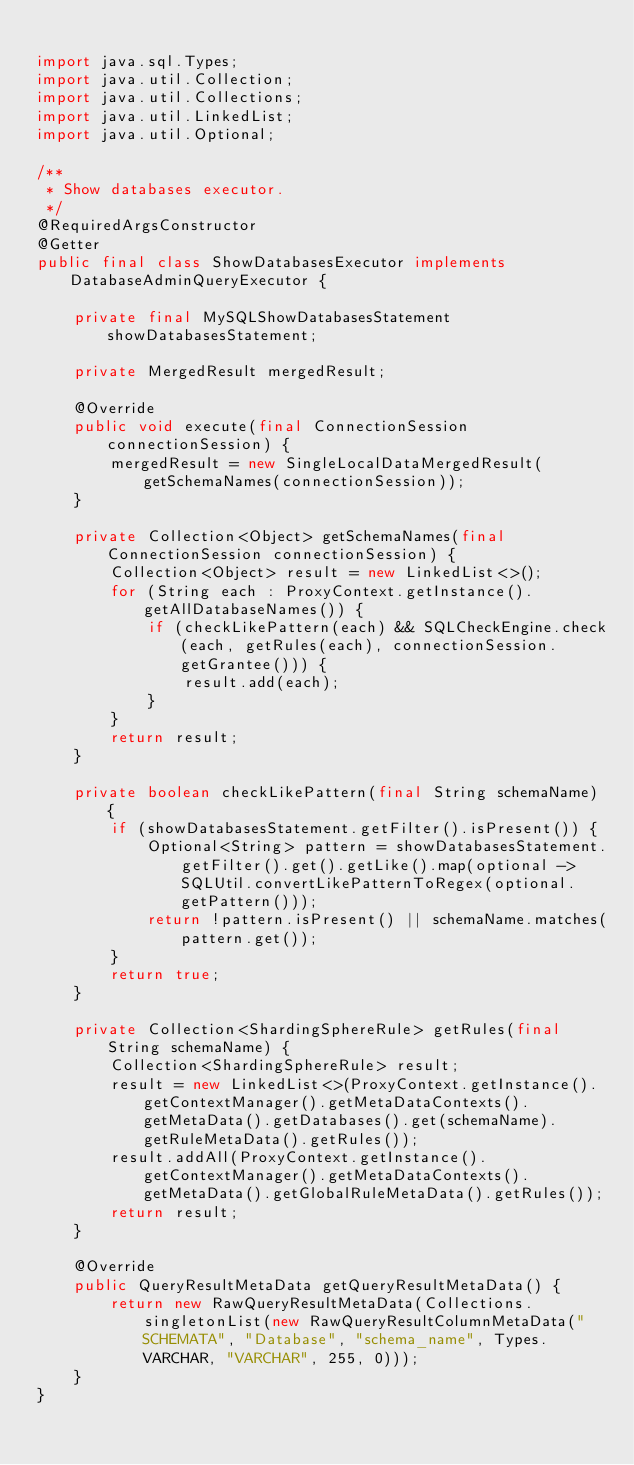Convert code to text. <code><loc_0><loc_0><loc_500><loc_500><_Java_>
import java.sql.Types;
import java.util.Collection;
import java.util.Collections;
import java.util.LinkedList;
import java.util.Optional;

/**
 * Show databases executor.
 */
@RequiredArgsConstructor
@Getter
public final class ShowDatabasesExecutor implements DatabaseAdminQueryExecutor {
    
    private final MySQLShowDatabasesStatement showDatabasesStatement;
    
    private MergedResult mergedResult;
    
    @Override
    public void execute(final ConnectionSession connectionSession) {
        mergedResult = new SingleLocalDataMergedResult(getSchemaNames(connectionSession));
    }
    
    private Collection<Object> getSchemaNames(final ConnectionSession connectionSession) {
        Collection<Object> result = new LinkedList<>();
        for (String each : ProxyContext.getInstance().getAllDatabaseNames()) {
            if (checkLikePattern(each) && SQLCheckEngine.check(each, getRules(each), connectionSession.getGrantee())) {
                result.add(each);
            }
        }
        return result;
    }
    
    private boolean checkLikePattern(final String schemaName) {
        if (showDatabasesStatement.getFilter().isPresent()) {
            Optional<String> pattern = showDatabasesStatement.getFilter().get().getLike().map(optional -> SQLUtil.convertLikePatternToRegex(optional.getPattern()));
            return !pattern.isPresent() || schemaName.matches(pattern.get());
        }
        return true;
    }
    
    private Collection<ShardingSphereRule> getRules(final String schemaName) {
        Collection<ShardingSphereRule> result;
        result = new LinkedList<>(ProxyContext.getInstance().getContextManager().getMetaDataContexts().getMetaData().getDatabases().get(schemaName).getRuleMetaData().getRules());
        result.addAll(ProxyContext.getInstance().getContextManager().getMetaDataContexts().getMetaData().getGlobalRuleMetaData().getRules());
        return result;
    }
    
    @Override
    public QueryResultMetaData getQueryResultMetaData() {
        return new RawQueryResultMetaData(Collections.singletonList(new RawQueryResultColumnMetaData("SCHEMATA", "Database", "schema_name", Types.VARCHAR, "VARCHAR", 255, 0)));
    }
}
</code> 